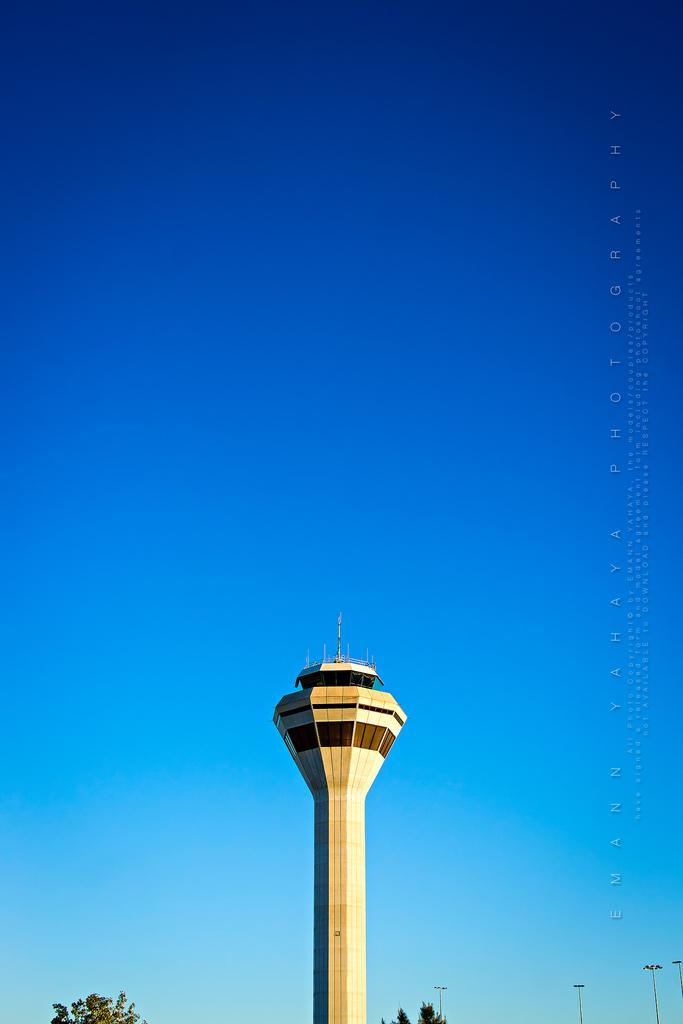What type of structure is in the image? There is a concrete tower in the image. What other natural elements can be seen in the image? There are trees in the image. Where are the street lights located in the image? Street lights are visible in the bottom right corner of the image. What is visible at the top of the image? The sky is visible at the top of the image. Can you describe any additional features on the image? There is a watermark on the right side of the image. What type of music is being played in the image? There is no indication of music being played in the image. 